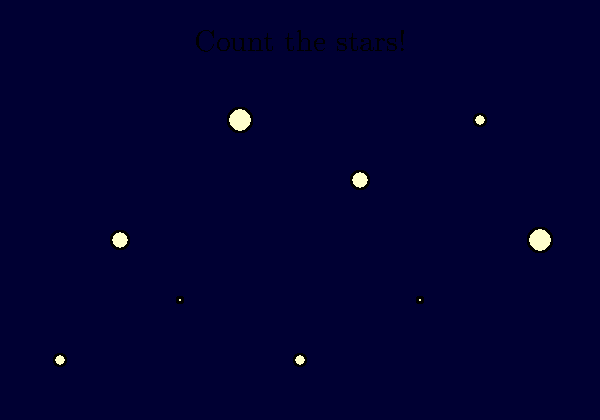How many stars can you count in the night sky? Remember, stars come in different sizes! Let's count the stars together:

1. First, we need to look carefully at the entire picture.
2. We can see that there are stars of different sizes in the sky.
3. Let's count each star, no matter its size:
   - We see 2 very big stars
   - We see 3 medium-sized stars
   - We see 4 small stars
4. Now, let's add them all up:
   $2 + 3 + 4 = 9$

So, even though the stars are different sizes, we count each one as a star.
Answer: 9 stars 